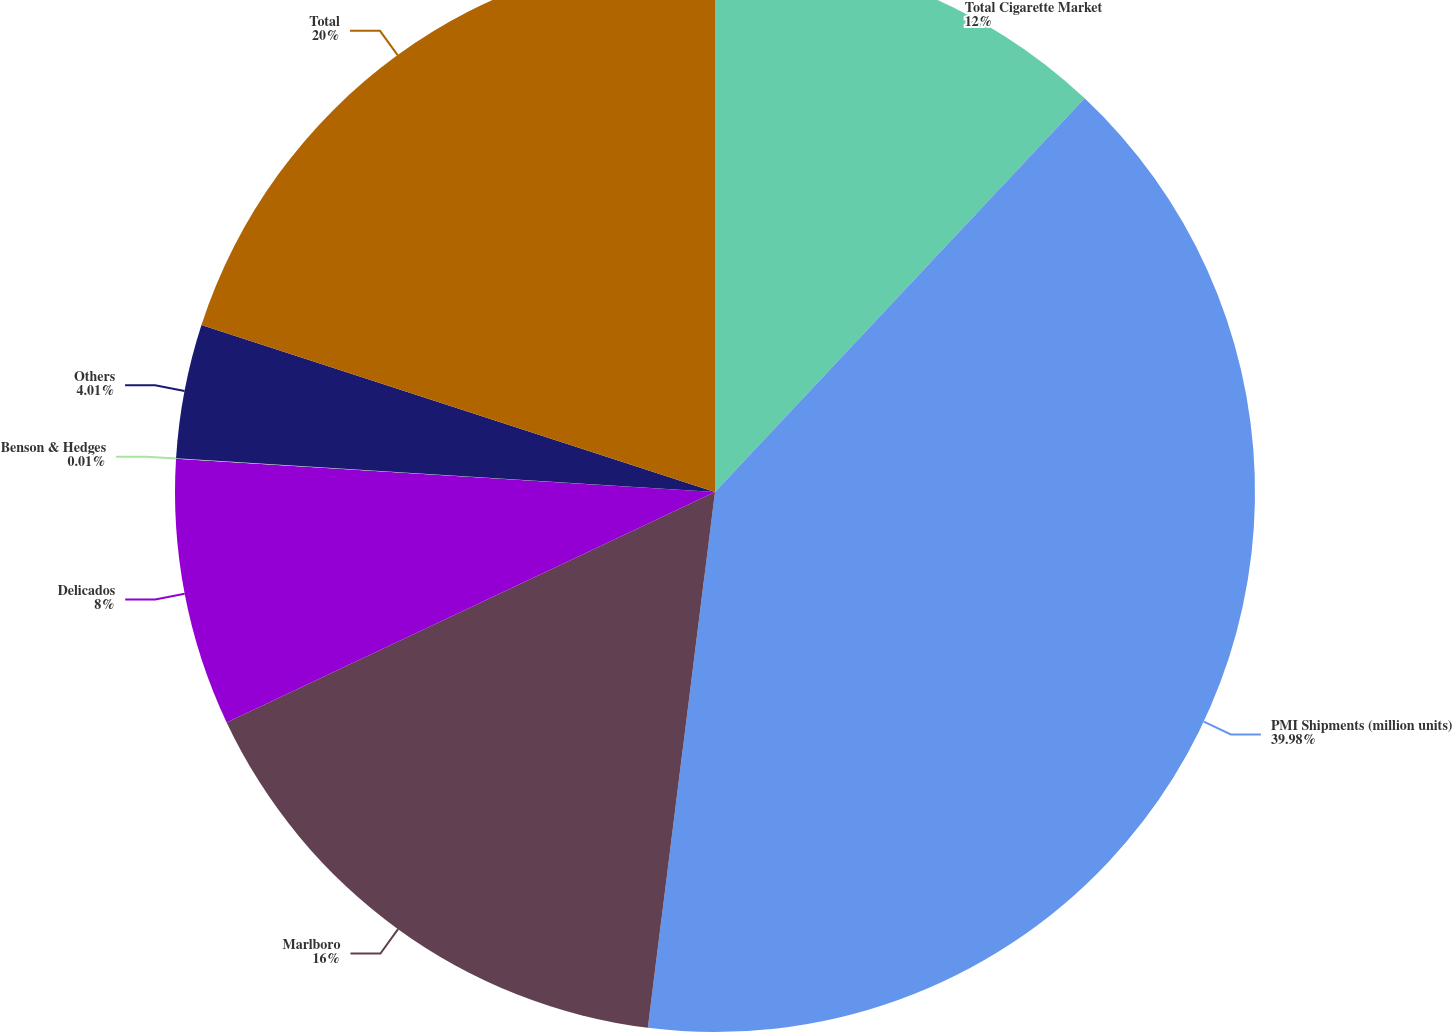<chart> <loc_0><loc_0><loc_500><loc_500><pie_chart><fcel>Total Cigarette Market<fcel>PMI Shipments (million units)<fcel>Marlboro<fcel>Delicados<fcel>Benson & Hedges<fcel>Others<fcel>Total<nl><fcel>12.0%<fcel>39.99%<fcel>16.0%<fcel>8.0%<fcel>0.01%<fcel>4.01%<fcel>20.0%<nl></chart> 